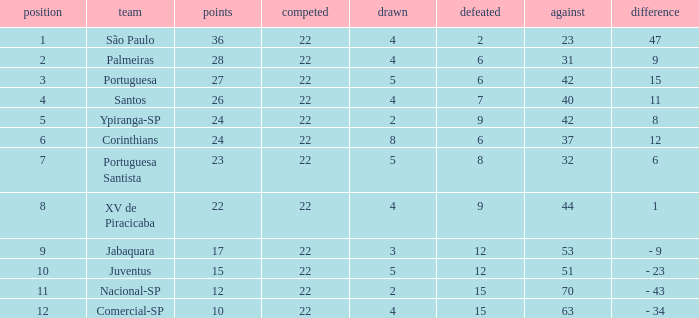Could you parse the entire table? {'header': ['position', 'team', 'points', 'competed', 'drawn', 'defeated', 'against', 'difference'], 'rows': [['1', 'São Paulo', '36', '22', '4', '2', '23', '47'], ['2', 'Palmeiras', '28', '22', '4', '6', '31', '9'], ['3', 'Portuguesa', '27', '22', '5', '6', '42', '15'], ['4', 'Santos', '26', '22', '4', '7', '40', '11'], ['5', 'Ypiranga-SP', '24', '22', '2', '9', '42', '8'], ['6', 'Corinthians', '24', '22', '8', '6', '37', '12'], ['7', 'Portuguesa Santista', '23', '22', '5', '8', '32', '6'], ['8', 'XV de Piracicaba', '22', '22', '4', '9', '44', '1'], ['9', 'Jabaquara', '17', '22', '3', '12', '53', '- 9'], ['10', 'Juventus', '15', '22', '5', '12', '51', '- 23'], ['11', 'Nacional-SP', '12', '22', '2', '15', '70', '- 43'], ['12', 'Comercial-SP', '10', '22', '4', '15', '63', '- 34']]} Which Played has a Lost larger than 9, and a Points smaller than 15, and a Position smaller than 12, and a Drawn smaller than 2? None. 